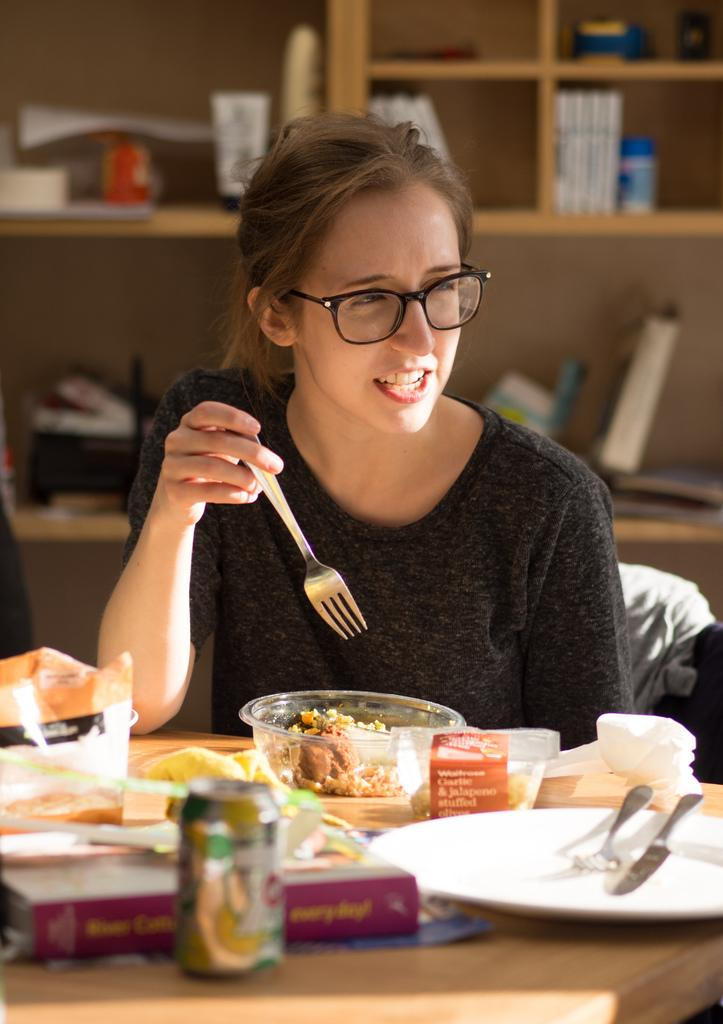What is the woman in the image doing? The woman is sitting on a chair in the image. What can be seen on the table in the image? There is a bowl, food, a fork, a plate, and tissues on the table in the image. What is the purpose of the racks at the back side? The purpose of the racks at the back side is not specified in the provided facts. How many items are on the table in the image? There are six items on the table in the image: a bowl, food, a fork, a plate, and tissues. What type of country is depicted in the image? There is no country depicted in the image; it features a woman sitting on a chair and items on a table. How many beans are visible on the plate in the image? There is no mention of beans in the image; the plate contains food, but the specific contents are not specified. 